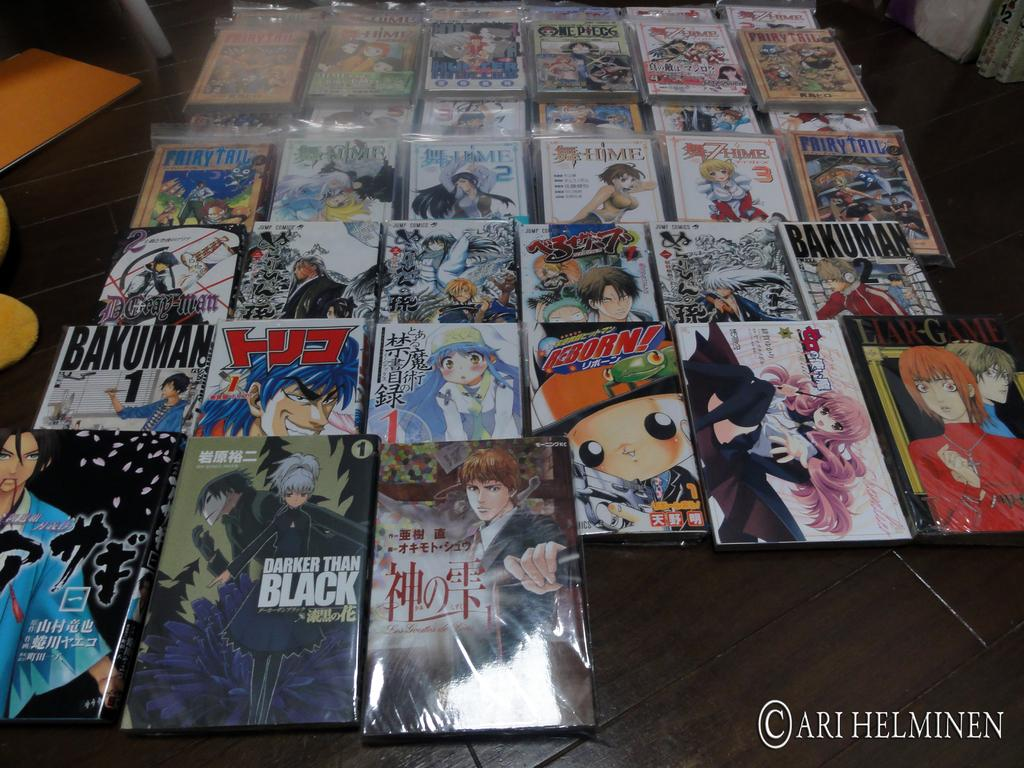Provide a one-sentence caption for the provided image. The picture here is from the artist Ari Helminen. 